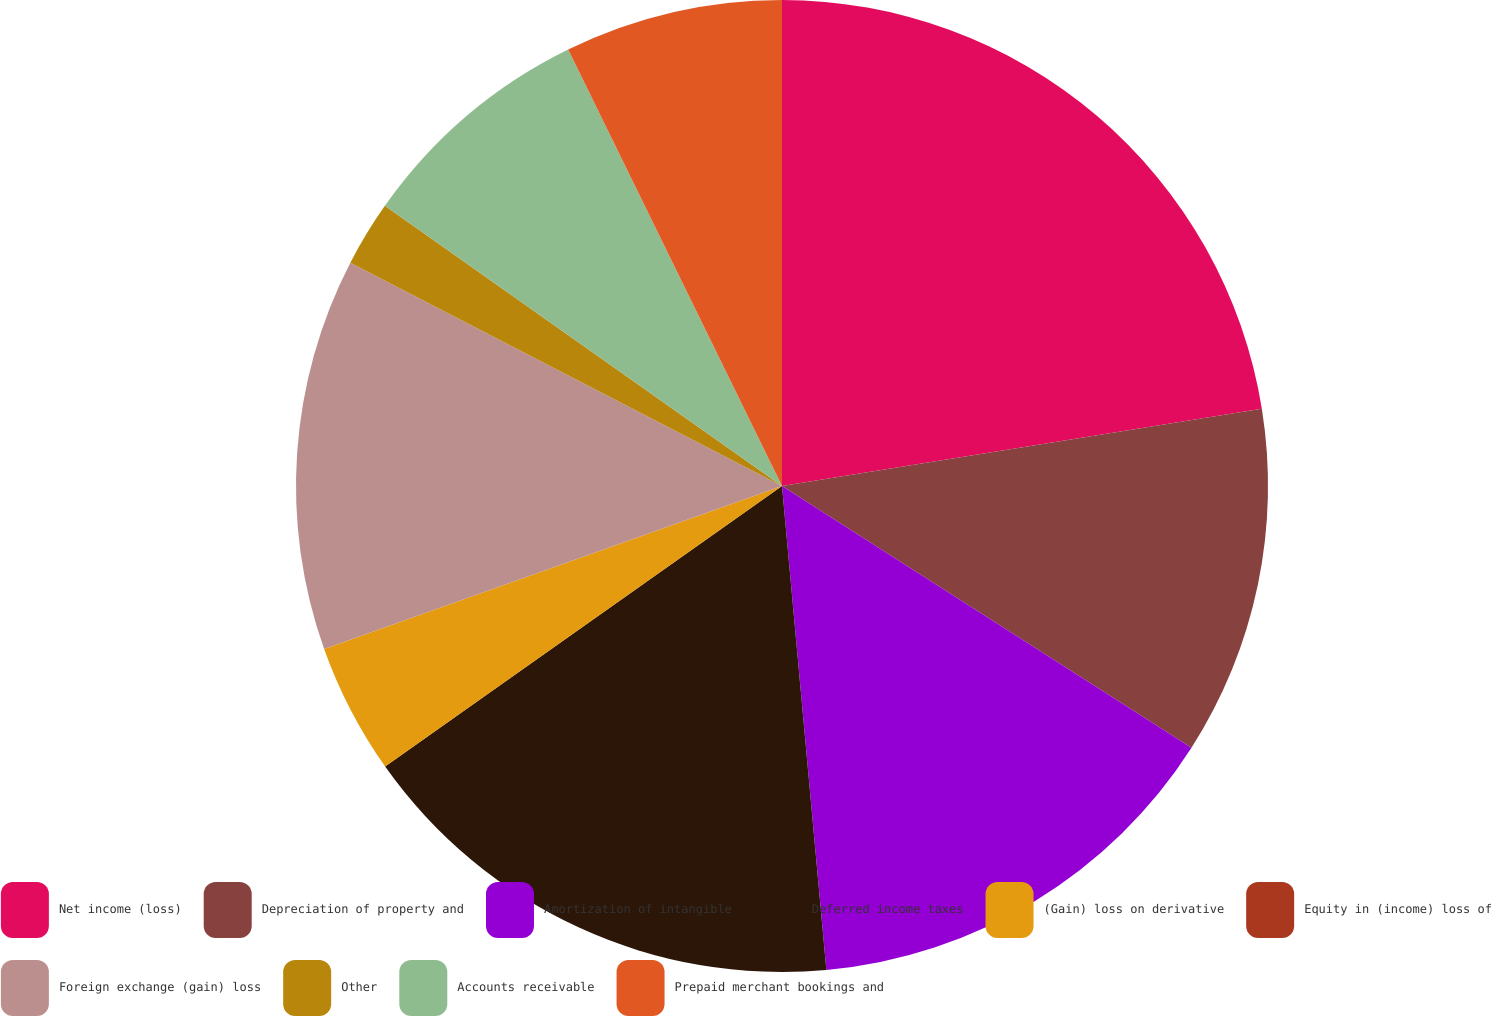Convert chart to OTSL. <chart><loc_0><loc_0><loc_500><loc_500><pie_chart><fcel>Net income (loss)<fcel>Depreciation of property and<fcel>Amortization of intangible<fcel>Deferred income taxes<fcel>(Gain) loss on derivative<fcel>Equity in (income) loss of<fcel>Foreign exchange (gain) loss<fcel>Other<fcel>Accounts receivable<fcel>Prepaid merchant bookings and<nl><fcel>22.46%<fcel>11.59%<fcel>14.49%<fcel>16.66%<fcel>4.35%<fcel>0.0%<fcel>13.04%<fcel>2.18%<fcel>7.97%<fcel>7.25%<nl></chart> 